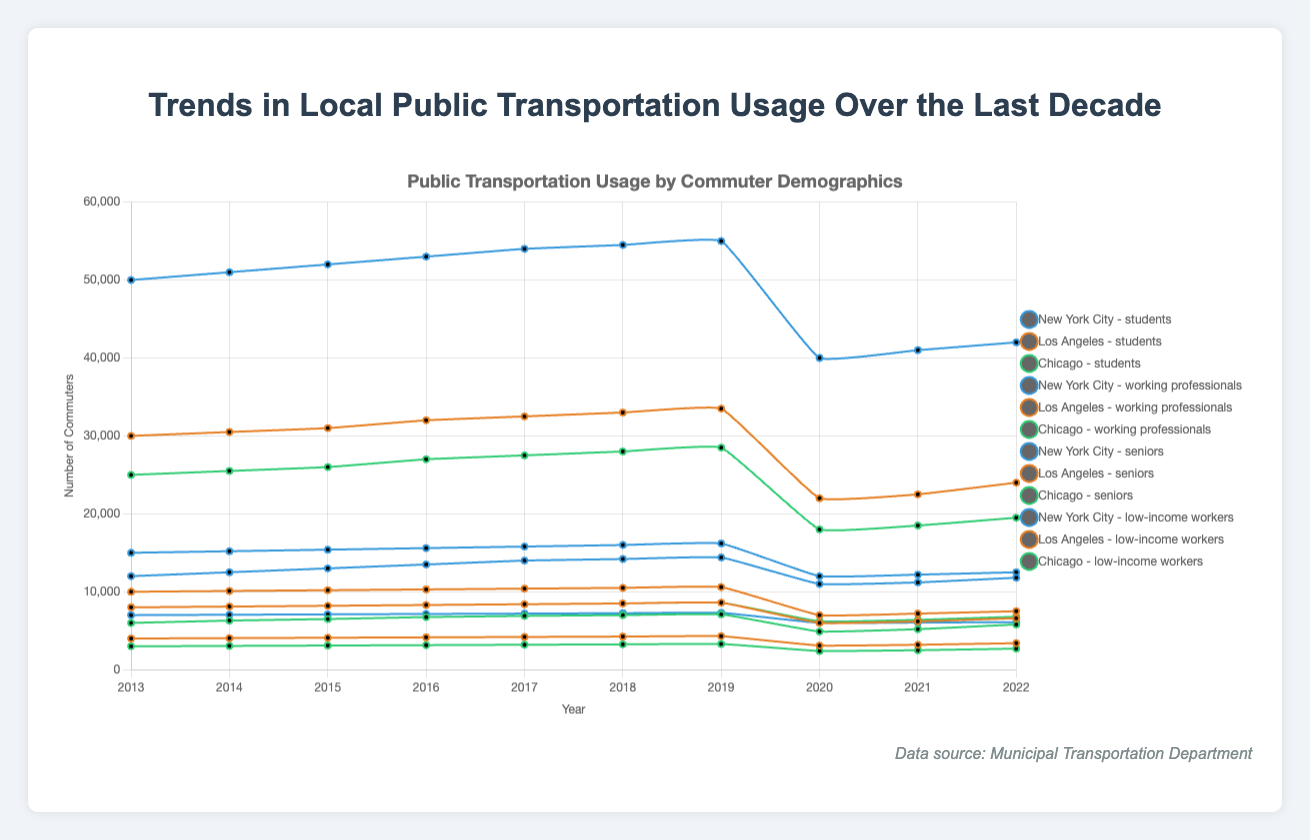How did transportation usage change for students in New York City from 2019 to 2020? Look at the figures for students in New York City for the years 2019 and 2020. In 2019, it was 14,400 and in 2020, it dropped to 11,000. The change is 14,400 - 11,000 = 3,400
Answer: 3,400 decrease Did senior commuters in Los Angeles show an increase or decrease in public transportation usage from 2020 to 2021? Look at the figures for seniors in Los Angeles for the years 2020 and 2021. In 2020, the usage was 3,100 and in 2021, it increased to 3,200. Since 3,200 is greater than 3,100, there was an increase
Answer: Increase Among the three cities, which had the highest number of working professionals using public transportation in 2018? Check the figures for working professionals in 2018 for New York City, Los Angeles, and Chicago. New York City had 54,500, Los Angeles had 33,000, and Chicago had 28,000. The highest number is 54,500 in New York City
Answer: New York City What was the average number of low-income workers using public transportation in Chicago across the entire period? Add the values for each year for low-income workers in Chicago and divide by the number of years. The sum is 8,000 + 8,100 + 8,200 + 8,300 + 8,400 + 8,500 + 8,600 + 6,200 + 6,400 + 6,800 = 77,500. The average is 77,500 / 10 = 7,750
Answer: 7,750 How did the transportation usage trends for students in Los Angeles compare to students in Chicago over the last decade? Look at the trends for students in Los Angeles and Chicago from 2013 to 2022. Both cities show an initial increase followed by a sharp decline in 2020. The numbers in Los Angeles decreased more consistently than in Chicago after 2020. Overall, similar trends but with varying magnitudes
Answer: Similar trends with varying magnitudes Which city's seniors saw the least variation in transportation usage over the last decade? To find the city with the least variation, compare the fluctuations for seniors in New York City, Los Angeles, and Chicago. New York City fluctuates from 7,000 to 7,300, while Los Angeles ranges from 4,000 to 4,300, and Chicago ranges from 3,000 to 3,300. The ranges are relatively small, but New York City's seniors have the tightest range
Answer: New York City By how much did public transportation use by working professionals in New York City change from 2018 to 2020? Look at working professionals in New York City in 2018 (54,500) and 2020 (40,000). The change is 54,500 - 40,000 = 14,500 decrease
Answer: 14,500 decrease What color represents data for students in Chicago on the chart? Each city is color-coded, and Chicago is represented in green. Therefore, the data for students in Chicago is also in green
Answer: Green 